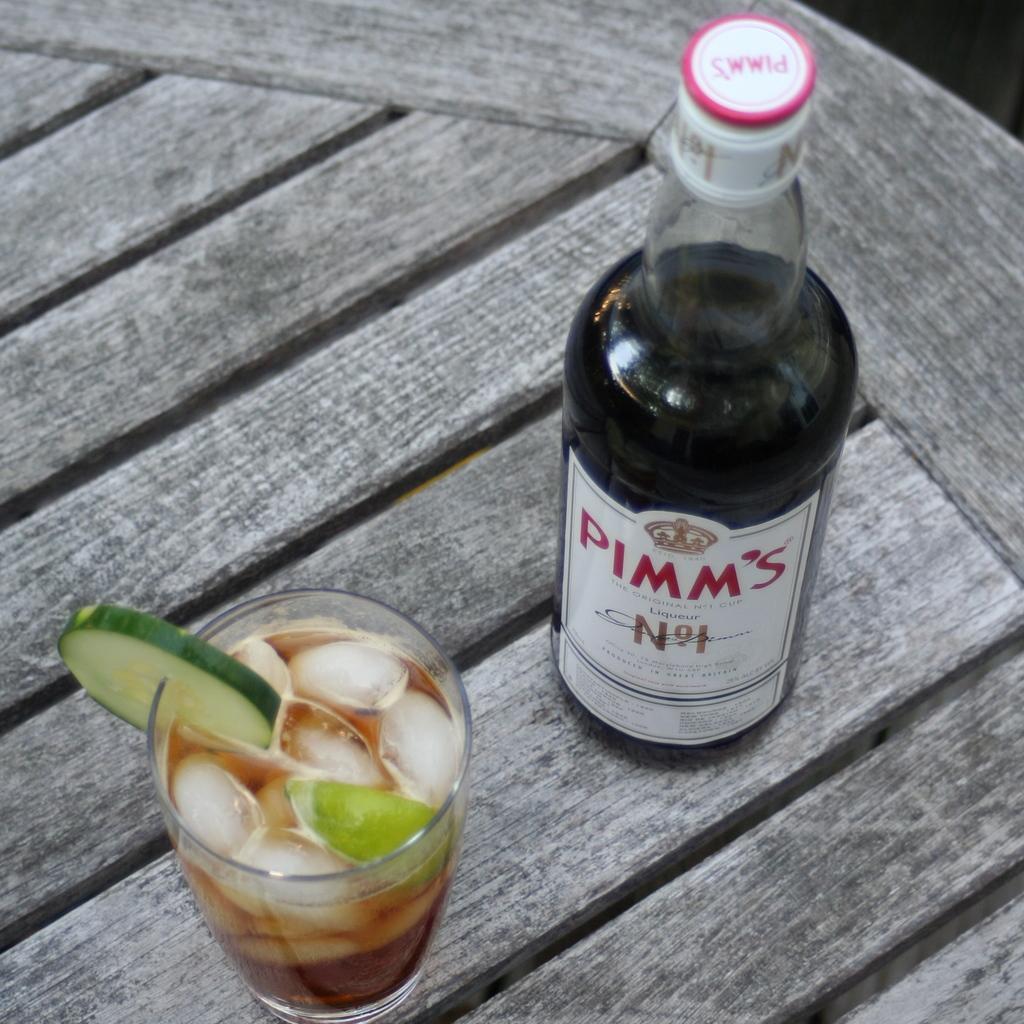Could you give a brief overview of what you see in this image? In this Image I see a bottle and glass in which there are ice and a vegetable slice over here. 